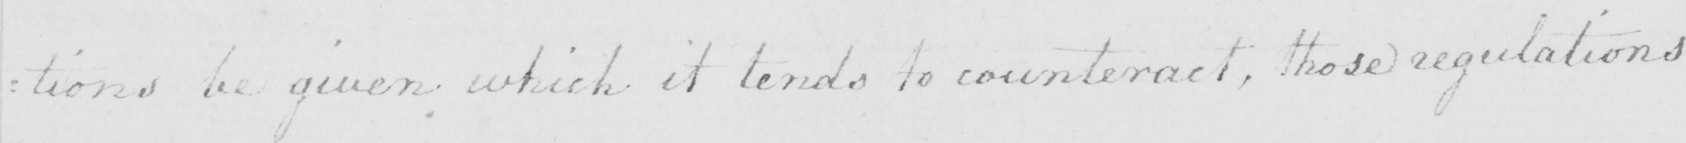Can you tell me what this handwritten text says? : tions be given which it tends to counteract , those regulations 